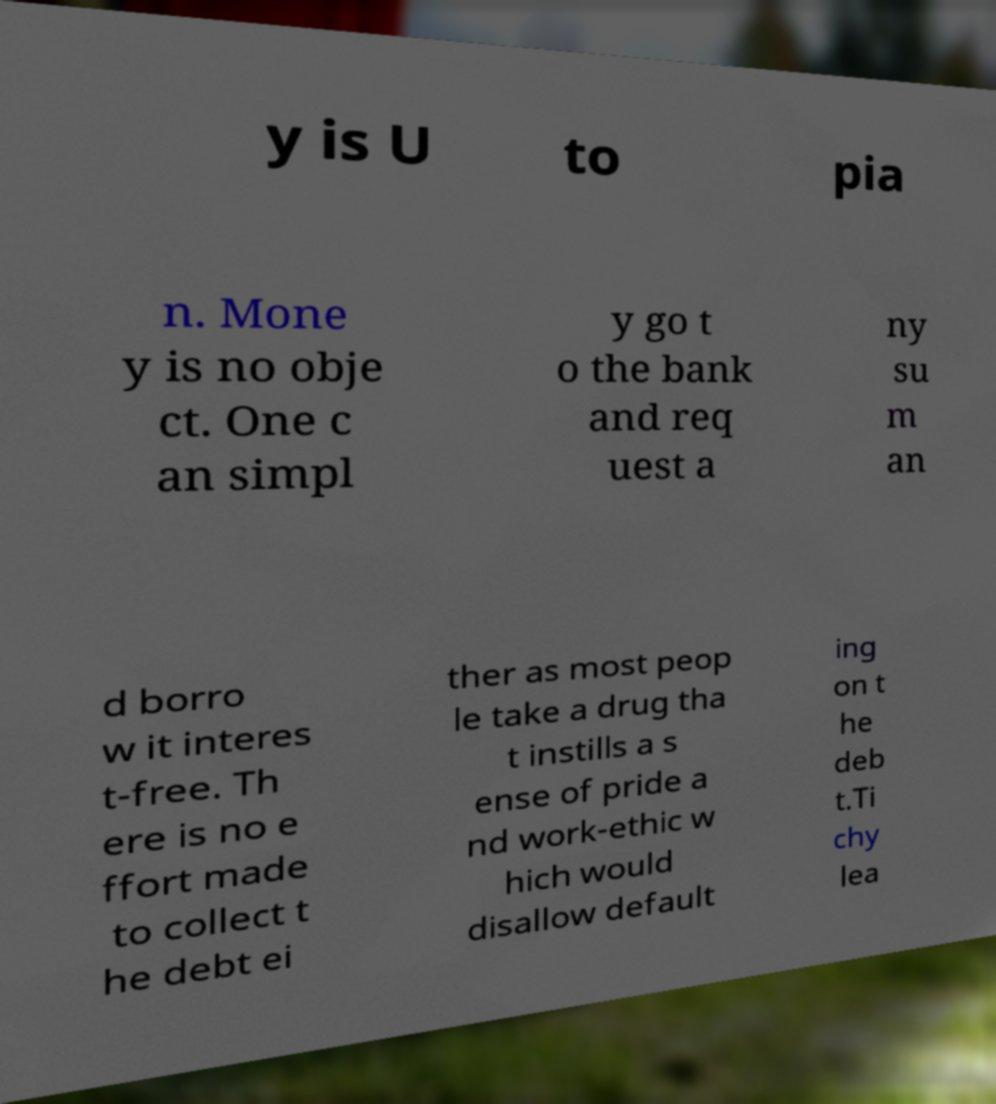Can you accurately transcribe the text from the provided image for me? y is U to pia n. Mone y is no obje ct. One c an simpl y go t o the bank and req uest a ny su m an d borro w it interes t-free. Th ere is no e ffort made to collect t he debt ei ther as most peop le take a drug tha t instills a s ense of pride a nd work-ethic w hich would disallow default ing on t he deb t.Ti chy lea 